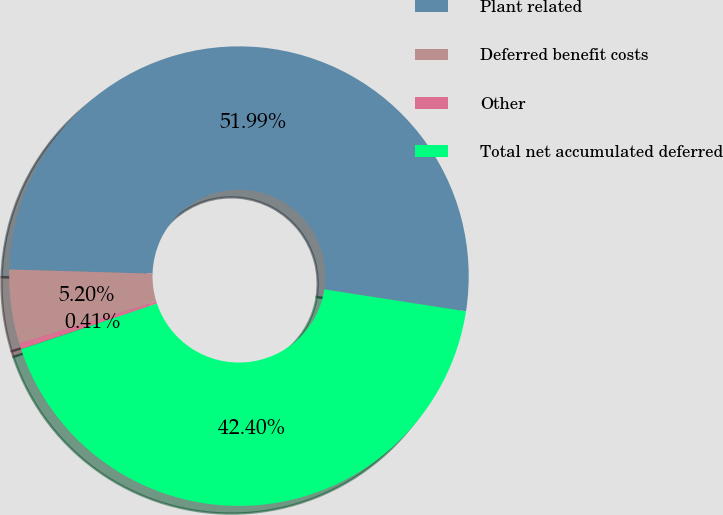Convert chart to OTSL. <chart><loc_0><loc_0><loc_500><loc_500><pie_chart><fcel>Plant related<fcel>Deferred benefit costs<fcel>Other<fcel>Total net accumulated deferred<nl><fcel>51.99%<fcel>5.2%<fcel>0.41%<fcel>42.4%<nl></chart> 